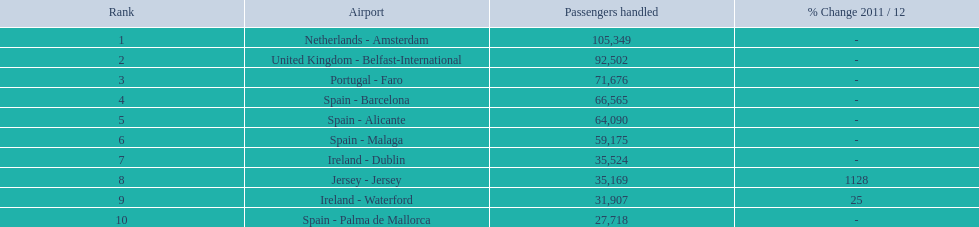What is the top position? 1. What is the aviation facility? Netherlands - Amsterdam. 